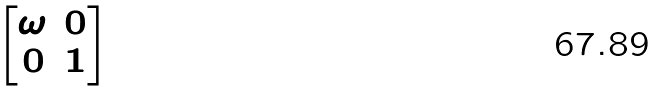<formula> <loc_0><loc_0><loc_500><loc_500>\begin{bmatrix} \omega & 0 \\ 0 & 1 \\ \end{bmatrix}</formula> 